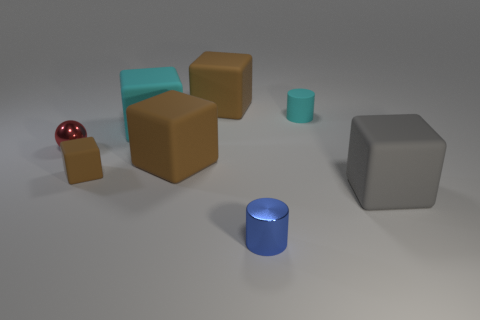Can you describe the colors and materials of the blocks in the image? Certainly! In the image, there are several blocks, each with distinct colors and materials. Some of the blocks appear to have a matte finish, with colors including grey, brown, and teal. Additionally, there's a shiny, reflective red sphere. The diverse textures and colors add an interesting variety to the composition. 